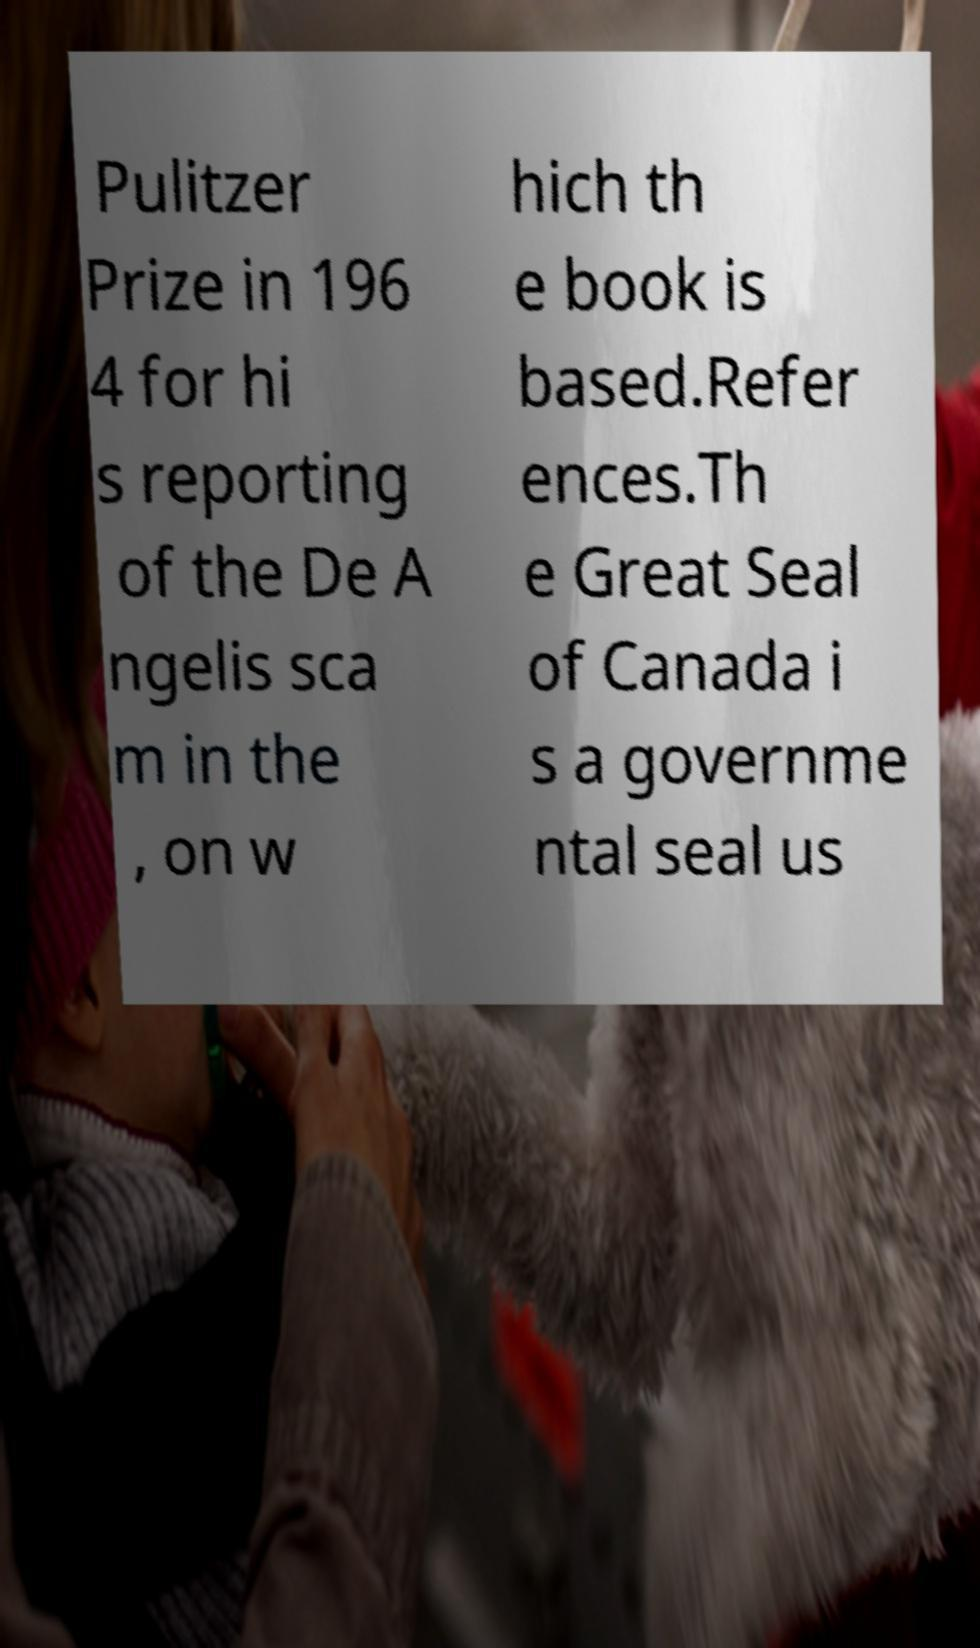I need the written content from this picture converted into text. Can you do that? Pulitzer Prize in 196 4 for hi s reporting of the De A ngelis sca m in the , on w hich th e book is based.Refer ences.Th e Great Seal of Canada i s a governme ntal seal us 